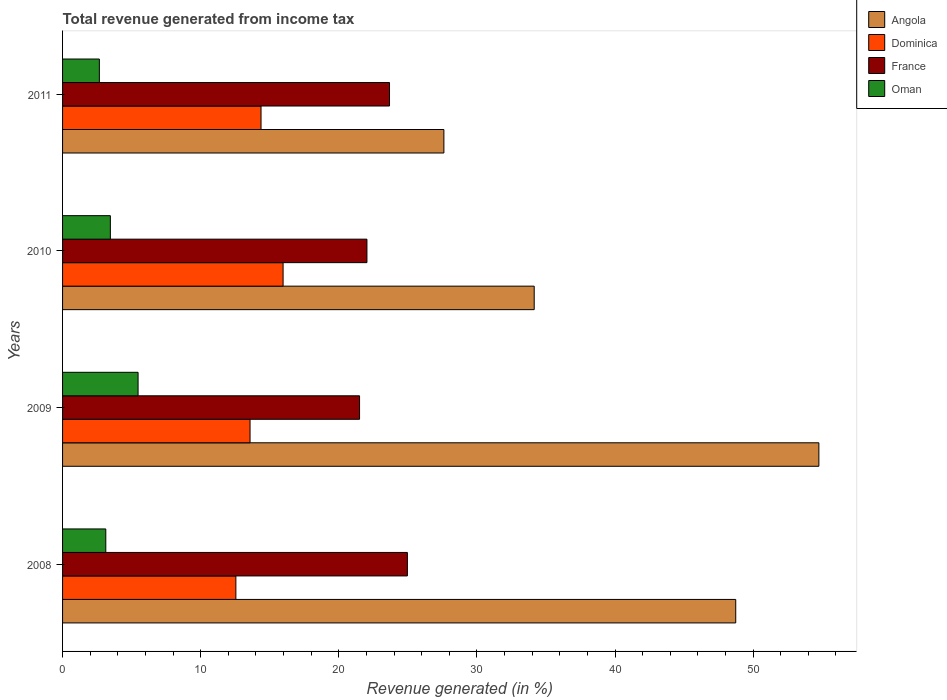How many bars are there on the 1st tick from the top?
Keep it short and to the point. 4. How many bars are there on the 3rd tick from the bottom?
Provide a succinct answer. 4. What is the total revenue generated in Dominica in 2011?
Offer a terse response. 14.37. Across all years, what is the maximum total revenue generated in France?
Provide a short and direct response. 24.97. Across all years, what is the minimum total revenue generated in Dominica?
Make the answer very short. 12.55. In which year was the total revenue generated in Angola maximum?
Make the answer very short. 2009. What is the total total revenue generated in Oman in the graph?
Provide a short and direct response. 14.72. What is the difference between the total revenue generated in Dominica in 2009 and that in 2011?
Your response must be concise. -0.8. What is the difference between the total revenue generated in France in 2011 and the total revenue generated in Oman in 2008?
Provide a succinct answer. 20.54. What is the average total revenue generated in France per year?
Make the answer very short. 23.05. In the year 2011, what is the difference between the total revenue generated in Oman and total revenue generated in France?
Give a very brief answer. -21.01. In how many years, is the total revenue generated in Angola greater than 34 %?
Offer a very short reply. 3. What is the ratio of the total revenue generated in Angola in 2008 to that in 2011?
Ensure brevity in your answer.  1.77. Is the total revenue generated in Angola in 2008 less than that in 2010?
Ensure brevity in your answer.  No. Is the difference between the total revenue generated in Oman in 2008 and 2010 greater than the difference between the total revenue generated in France in 2008 and 2010?
Provide a short and direct response. No. What is the difference between the highest and the second highest total revenue generated in Oman?
Ensure brevity in your answer.  2.01. What is the difference between the highest and the lowest total revenue generated in France?
Offer a very short reply. 3.46. In how many years, is the total revenue generated in Dominica greater than the average total revenue generated in Dominica taken over all years?
Keep it short and to the point. 2. Is the sum of the total revenue generated in France in 2008 and 2011 greater than the maximum total revenue generated in Oman across all years?
Your answer should be very brief. Yes. Is it the case that in every year, the sum of the total revenue generated in Oman and total revenue generated in France is greater than the sum of total revenue generated in Angola and total revenue generated in Dominica?
Keep it short and to the point. No. What does the 4th bar from the top in 2011 represents?
Offer a terse response. Angola. What does the 2nd bar from the bottom in 2008 represents?
Your response must be concise. Dominica. Is it the case that in every year, the sum of the total revenue generated in Oman and total revenue generated in Dominica is greater than the total revenue generated in Angola?
Offer a terse response. No. Are all the bars in the graph horizontal?
Your answer should be compact. Yes. Are the values on the major ticks of X-axis written in scientific E-notation?
Your answer should be very brief. No. Does the graph contain any zero values?
Provide a succinct answer. No. Does the graph contain grids?
Your answer should be very brief. No. What is the title of the graph?
Make the answer very short. Total revenue generated from income tax. Does "Czech Republic" appear as one of the legend labels in the graph?
Provide a short and direct response. No. What is the label or title of the X-axis?
Provide a succinct answer. Revenue generated (in %). What is the Revenue generated (in %) in Angola in 2008?
Offer a terse response. 48.74. What is the Revenue generated (in %) of Dominica in 2008?
Your answer should be compact. 12.55. What is the Revenue generated (in %) of France in 2008?
Provide a succinct answer. 24.97. What is the Revenue generated (in %) of Oman in 2008?
Keep it short and to the point. 3.13. What is the Revenue generated (in %) in Angola in 2009?
Provide a succinct answer. 54.76. What is the Revenue generated (in %) in Dominica in 2009?
Your response must be concise. 13.57. What is the Revenue generated (in %) of France in 2009?
Your answer should be very brief. 21.5. What is the Revenue generated (in %) of Oman in 2009?
Your answer should be compact. 5.47. What is the Revenue generated (in %) in Angola in 2010?
Provide a short and direct response. 34.15. What is the Revenue generated (in %) of Dominica in 2010?
Your response must be concise. 15.97. What is the Revenue generated (in %) of France in 2010?
Your answer should be compact. 22.04. What is the Revenue generated (in %) in Oman in 2010?
Offer a terse response. 3.46. What is the Revenue generated (in %) in Angola in 2011?
Your answer should be very brief. 27.61. What is the Revenue generated (in %) of Dominica in 2011?
Your answer should be compact. 14.37. What is the Revenue generated (in %) in France in 2011?
Keep it short and to the point. 23.67. What is the Revenue generated (in %) in Oman in 2011?
Your answer should be compact. 2.66. Across all years, what is the maximum Revenue generated (in %) of Angola?
Your answer should be very brief. 54.76. Across all years, what is the maximum Revenue generated (in %) of Dominica?
Your answer should be compact. 15.97. Across all years, what is the maximum Revenue generated (in %) in France?
Offer a very short reply. 24.97. Across all years, what is the maximum Revenue generated (in %) of Oman?
Give a very brief answer. 5.47. Across all years, what is the minimum Revenue generated (in %) in Angola?
Offer a very short reply. 27.61. Across all years, what is the minimum Revenue generated (in %) in Dominica?
Offer a terse response. 12.55. Across all years, what is the minimum Revenue generated (in %) of France?
Your answer should be compact. 21.5. Across all years, what is the minimum Revenue generated (in %) of Oman?
Your answer should be compact. 2.66. What is the total Revenue generated (in %) of Angola in the graph?
Your response must be concise. 165.26. What is the total Revenue generated (in %) of Dominica in the graph?
Ensure brevity in your answer.  56.46. What is the total Revenue generated (in %) in France in the graph?
Your answer should be compact. 92.18. What is the total Revenue generated (in %) in Oman in the graph?
Ensure brevity in your answer.  14.72. What is the difference between the Revenue generated (in %) of Angola in 2008 and that in 2009?
Give a very brief answer. -6.02. What is the difference between the Revenue generated (in %) in Dominica in 2008 and that in 2009?
Offer a terse response. -1.03. What is the difference between the Revenue generated (in %) of France in 2008 and that in 2009?
Give a very brief answer. 3.46. What is the difference between the Revenue generated (in %) in Oman in 2008 and that in 2009?
Your answer should be very brief. -2.34. What is the difference between the Revenue generated (in %) in Angola in 2008 and that in 2010?
Offer a very short reply. 14.59. What is the difference between the Revenue generated (in %) of Dominica in 2008 and that in 2010?
Your answer should be compact. -3.42. What is the difference between the Revenue generated (in %) of France in 2008 and that in 2010?
Offer a very short reply. 2.93. What is the difference between the Revenue generated (in %) in Oman in 2008 and that in 2010?
Give a very brief answer. -0.33. What is the difference between the Revenue generated (in %) in Angola in 2008 and that in 2011?
Offer a terse response. 21.13. What is the difference between the Revenue generated (in %) in Dominica in 2008 and that in 2011?
Your answer should be compact. -1.82. What is the difference between the Revenue generated (in %) in France in 2008 and that in 2011?
Give a very brief answer. 1.29. What is the difference between the Revenue generated (in %) of Oman in 2008 and that in 2011?
Give a very brief answer. 0.47. What is the difference between the Revenue generated (in %) of Angola in 2009 and that in 2010?
Offer a terse response. 20.61. What is the difference between the Revenue generated (in %) in Dominica in 2009 and that in 2010?
Offer a terse response. -2.39. What is the difference between the Revenue generated (in %) in France in 2009 and that in 2010?
Keep it short and to the point. -0.53. What is the difference between the Revenue generated (in %) in Oman in 2009 and that in 2010?
Offer a terse response. 2.01. What is the difference between the Revenue generated (in %) in Angola in 2009 and that in 2011?
Offer a terse response. 27.15. What is the difference between the Revenue generated (in %) in Dominica in 2009 and that in 2011?
Offer a very short reply. -0.8. What is the difference between the Revenue generated (in %) in France in 2009 and that in 2011?
Your answer should be very brief. -2.17. What is the difference between the Revenue generated (in %) of Oman in 2009 and that in 2011?
Offer a terse response. 2.8. What is the difference between the Revenue generated (in %) in Angola in 2010 and that in 2011?
Provide a short and direct response. 6.54. What is the difference between the Revenue generated (in %) in Dominica in 2010 and that in 2011?
Provide a succinct answer. 1.6. What is the difference between the Revenue generated (in %) in France in 2010 and that in 2011?
Provide a short and direct response. -1.63. What is the difference between the Revenue generated (in %) of Oman in 2010 and that in 2011?
Keep it short and to the point. 0.8. What is the difference between the Revenue generated (in %) in Angola in 2008 and the Revenue generated (in %) in Dominica in 2009?
Ensure brevity in your answer.  35.17. What is the difference between the Revenue generated (in %) in Angola in 2008 and the Revenue generated (in %) in France in 2009?
Offer a terse response. 27.24. What is the difference between the Revenue generated (in %) of Angola in 2008 and the Revenue generated (in %) of Oman in 2009?
Provide a short and direct response. 43.27. What is the difference between the Revenue generated (in %) of Dominica in 2008 and the Revenue generated (in %) of France in 2009?
Keep it short and to the point. -8.96. What is the difference between the Revenue generated (in %) of Dominica in 2008 and the Revenue generated (in %) of Oman in 2009?
Offer a terse response. 7.08. What is the difference between the Revenue generated (in %) in France in 2008 and the Revenue generated (in %) in Oman in 2009?
Offer a terse response. 19.5. What is the difference between the Revenue generated (in %) in Angola in 2008 and the Revenue generated (in %) in Dominica in 2010?
Ensure brevity in your answer.  32.77. What is the difference between the Revenue generated (in %) of Angola in 2008 and the Revenue generated (in %) of France in 2010?
Make the answer very short. 26.7. What is the difference between the Revenue generated (in %) of Angola in 2008 and the Revenue generated (in %) of Oman in 2010?
Provide a succinct answer. 45.28. What is the difference between the Revenue generated (in %) in Dominica in 2008 and the Revenue generated (in %) in France in 2010?
Your answer should be compact. -9.49. What is the difference between the Revenue generated (in %) in Dominica in 2008 and the Revenue generated (in %) in Oman in 2010?
Your answer should be very brief. 9.09. What is the difference between the Revenue generated (in %) of France in 2008 and the Revenue generated (in %) of Oman in 2010?
Keep it short and to the point. 21.51. What is the difference between the Revenue generated (in %) in Angola in 2008 and the Revenue generated (in %) in Dominica in 2011?
Make the answer very short. 34.37. What is the difference between the Revenue generated (in %) of Angola in 2008 and the Revenue generated (in %) of France in 2011?
Offer a very short reply. 25.07. What is the difference between the Revenue generated (in %) in Angola in 2008 and the Revenue generated (in %) in Oman in 2011?
Make the answer very short. 46.08. What is the difference between the Revenue generated (in %) in Dominica in 2008 and the Revenue generated (in %) in France in 2011?
Your response must be concise. -11.12. What is the difference between the Revenue generated (in %) of Dominica in 2008 and the Revenue generated (in %) of Oman in 2011?
Ensure brevity in your answer.  9.88. What is the difference between the Revenue generated (in %) of France in 2008 and the Revenue generated (in %) of Oman in 2011?
Offer a terse response. 22.3. What is the difference between the Revenue generated (in %) in Angola in 2009 and the Revenue generated (in %) in Dominica in 2010?
Your response must be concise. 38.79. What is the difference between the Revenue generated (in %) in Angola in 2009 and the Revenue generated (in %) in France in 2010?
Provide a short and direct response. 32.72. What is the difference between the Revenue generated (in %) in Angola in 2009 and the Revenue generated (in %) in Oman in 2010?
Provide a short and direct response. 51.3. What is the difference between the Revenue generated (in %) of Dominica in 2009 and the Revenue generated (in %) of France in 2010?
Give a very brief answer. -8.46. What is the difference between the Revenue generated (in %) of Dominica in 2009 and the Revenue generated (in %) of Oman in 2010?
Your response must be concise. 10.11. What is the difference between the Revenue generated (in %) of France in 2009 and the Revenue generated (in %) of Oman in 2010?
Your answer should be very brief. 18.04. What is the difference between the Revenue generated (in %) in Angola in 2009 and the Revenue generated (in %) in Dominica in 2011?
Give a very brief answer. 40.39. What is the difference between the Revenue generated (in %) in Angola in 2009 and the Revenue generated (in %) in France in 2011?
Ensure brevity in your answer.  31.09. What is the difference between the Revenue generated (in %) in Angola in 2009 and the Revenue generated (in %) in Oman in 2011?
Your answer should be compact. 52.1. What is the difference between the Revenue generated (in %) in Dominica in 2009 and the Revenue generated (in %) in France in 2011?
Give a very brief answer. -10.1. What is the difference between the Revenue generated (in %) in Dominica in 2009 and the Revenue generated (in %) in Oman in 2011?
Offer a terse response. 10.91. What is the difference between the Revenue generated (in %) of France in 2009 and the Revenue generated (in %) of Oman in 2011?
Your answer should be very brief. 18.84. What is the difference between the Revenue generated (in %) of Angola in 2010 and the Revenue generated (in %) of Dominica in 2011?
Your response must be concise. 19.78. What is the difference between the Revenue generated (in %) in Angola in 2010 and the Revenue generated (in %) in France in 2011?
Give a very brief answer. 10.48. What is the difference between the Revenue generated (in %) in Angola in 2010 and the Revenue generated (in %) in Oman in 2011?
Your response must be concise. 31.49. What is the difference between the Revenue generated (in %) of Dominica in 2010 and the Revenue generated (in %) of France in 2011?
Offer a very short reply. -7.71. What is the difference between the Revenue generated (in %) in Dominica in 2010 and the Revenue generated (in %) in Oman in 2011?
Offer a terse response. 13.3. What is the difference between the Revenue generated (in %) in France in 2010 and the Revenue generated (in %) in Oman in 2011?
Ensure brevity in your answer.  19.37. What is the average Revenue generated (in %) in Angola per year?
Keep it short and to the point. 41.32. What is the average Revenue generated (in %) of Dominica per year?
Ensure brevity in your answer.  14.12. What is the average Revenue generated (in %) of France per year?
Give a very brief answer. 23.05. What is the average Revenue generated (in %) of Oman per year?
Provide a short and direct response. 3.68. In the year 2008, what is the difference between the Revenue generated (in %) of Angola and Revenue generated (in %) of Dominica?
Make the answer very short. 36.19. In the year 2008, what is the difference between the Revenue generated (in %) in Angola and Revenue generated (in %) in France?
Your response must be concise. 23.77. In the year 2008, what is the difference between the Revenue generated (in %) of Angola and Revenue generated (in %) of Oman?
Your answer should be compact. 45.61. In the year 2008, what is the difference between the Revenue generated (in %) in Dominica and Revenue generated (in %) in France?
Keep it short and to the point. -12.42. In the year 2008, what is the difference between the Revenue generated (in %) in Dominica and Revenue generated (in %) in Oman?
Ensure brevity in your answer.  9.42. In the year 2008, what is the difference between the Revenue generated (in %) in France and Revenue generated (in %) in Oman?
Your response must be concise. 21.84. In the year 2009, what is the difference between the Revenue generated (in %) in Angola and Revenue generated (in %) in Dominica?
Your answer should be very brief. 41.19. In the year 2009, what is the difference between the Revenue generated (in %) of Angola and Revenue generated (in %) of France?
Your response must be concise. 33.26. In the year 2009, what is the difference between the Revenue generated (in %) in Angola and Revenue generated (in %) in Oman?
Your answer should be very brief. 49.29. In the year 2009, what is the difference between the Revenue generated (in %) of Dominica and Revenue generated (in %) of France?
Provide a short and direct response. -7.93. In the year 2009, what is the difference between the Revenue generated (in %) in Dominica and Revenue generated (in %) in Oman?
Offer a terse response. 8.11. In the year 2009, what is the difference between the Revenue generated (in %) in France and Revenue generated (in %) in Oman?
Offer a terse response. 16.04. In the year 2010, what is the difference between the Revenue generated (in %) in Angola and Revenue generated (in %) in Dominica?
Offer a very short reply. 18.18. In the year 2010, what is the difference between the Revenue generated (in %) in Angola and Revenue generated (in %) in France?
Your answer should be compact. 12.11. In the year 2010, what is the difference between the Revenue generated (in %) in Angola and Revenue generated (in %) in Oman?
Offer a very short reply. 30.69. In the year 2010, what is the difference between the Revenue generated (in %) in Dominica and Revenue generated (in %) in France?
Your answer should be compact. -6.07. In the year 2010, what is the difference between the Revenue generated (in %) in Dominica and Revenue generated (in %) in Oman?
Your response must be concise. 12.51. In the year 2010, what is the difference between the Revenue generated (in %) of France and Revenue generated (in %) of Oman?
Your answer should be compact. 18.58. In the year 2011, what is the difference between the Revenue generated (in %) of Angola and Revenue generated (in %) of Dominica?
Your answer should be very brief. 13.24. In the year 2011, what is the difference between the Revenue generated (in %) in Angola and Revenue generated (in %) in France?
Ensure brevity in your answer.  3.94. In the year 2011, what is the difference between the Revenue generated (in %) in Angola and Revenue generated (in %) in Oman?
Your answer should be compact. 24.95. In the year 2011, what is the difference between the Revenue generated (in %) in Dominica and Revenue generated (in %) in France?
Ensure brevity in your answer.  -9.3. In the year 2011, what is the difference between the Revenue generated (in %) of Dominica and Revenue generated (in %) of Oman?
Offer a very short reply. 11.71. In the year 2011, what is the difference between the Revenue generated (in %) of France and Revenue generated (in %) of Oman?
Make the answer very short. 21.01. What is the ratio of the Revenue generated (in %) in Angola in 2008 to that in 2009?
Offer a terse response. 0.89. What is the ratio of the Revenue generated (in %) of Dominica in 2008 to that in 2009?
Ensure brevity in your answer.  0.92. What is the ratio of the Revenue generated (in %) in France in 2008 to that in 2009?
Offer a terse response. 1.16. What is the ratio of the Revenue generated (in %) of Oman in 2008 to that in 2009?
Provide a short and direct response. 0.57. What is the ratio of the Revenue generated (in %) of Angola in 2008 to that in 2010?
Give a very brief answer. 1.43. What is the ratio of the Revenue generated (in %) in Dominica in 2008 to that in 2010?
Offer a very short reply. 0.79. What is the ratio of the Revenue generated (in %) of France in 2008 to that in 2010?
Provide a short and direct response. 1.13. What is the ratio of the Revenue generated (in %) of Oman in 2008 to that in 2010?
Provide a short and direct response. 0.9. What is the ratio of the Revenue generated (in %) in Angola in 2008 to that in 2011?
Ensure brevity in your answer.  1.77. What is the ratio of the Revenue generated (in %) of Dominica in 2008 to that in 2011?
Provide a short and direct response. 0.87. What is the ratio of the Revenue generated (in %) of France in 2008 to that in 2011?
Make the answer very short. 1.05. What is the ratio of the Revenue generated (in %) in Oman in 2008 to that in 2011?
Offer a terse response. 1.18. What is the ratio of the Revenue generated (in %) in Angola in 2009 to that in 2010?
Provide a succinct answer. 1.6. What is the ratio of the Revenue generated (in %) of Dominica in 2009 to that in 2010?
Offer a terse response. 0.85. What is the ratio of the Revenue generated (in %) in France in 2009 to that in 2010?
Offer a terse response. 0.98. What is the ratio of the Revenue generated (in %) of Oman in 2009 to that in 2010?
Make the answer very short. 1.58. What is the ratio of the Revenue generated (in %) of Angola in 2009 to that in 2011?
Give a very brief answer. 1.98. What is the ratio of the Revenue generated (in %) in Dominica in 2009 to that in 2011?
Offer a very short reply. 0.94. What is the ratio of the Revenue generated (in %) of France in 2009 to that in 2011?
Your answer should be very brief. 0.91. What is the ratio of the Revenue generated (in %) of Oman in 2009 to that in 2011?
Offer a terse response. 2.05. What is the ratio of the Revenue generated (in %) in Angola in 2010 to that in 2011?
Your response must be concise. 1.24. What is the ratio of the Revenue generated (in %) of Dominica in 2010 to that in 2011?
Your answer should be very brief. 1.11. What is the ratio of the Revenue generated (in %) in Oman in 2010 to that in 2011?
Provide a short and direct response. 1.3. What is the difference between the highest and the second highest Revenue generated (in %) in Angola?
Make the answer very short. 6.02. What is the difference between the highest and the second highest Revenue generated (in %) of Dominica?
Offer a terse response. 1.6. What is the difference between the highest and the second highest Revenue generated (in %) of France?
Offer a very short reply. 1.29. What is the difference between the highest and the second highest Revenue generated (in %) in Oman?
Keep it short and to the point. 2.01. What is the difference between the highest and the lowest Revenue generated (in %) of Angola?
Make the answer very short. 27.15. What is the difference between the highest and the lowest Revenue generated (in %) in Dominica?
Offer a very short reply. 3.42. What is the difference between the highest and the lowest Revenue generated (in %) of France?
Your answer should be very brief. 3.46. What is the difference between the highest and the lowest Revenue generated (in %) in Oman?
Your answer should be very brief. 2.8. 